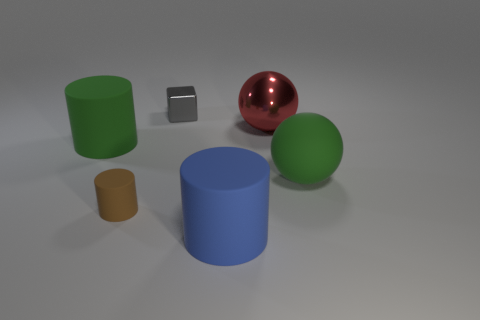How many small objects are either brown cylinders or blocks?
Offer a very short reply. 2. What is the color of the object that is both behind the green rubber cylinder and in front of the small gray block?
Offer a very short reply. Red. Do the brown thing and the green cylinder have the same material?
Ensure brevity in your answer.  Yes. What shape is the brown matte thing?
Ensure brevity in your answer.  Cylinder. There is a small thing in front of the green object that is to the right of the metal cube; what number of big objects are behind it?
Your answer should be compact. 3. There is another object that is the same shape as the red metal object; what color is it?
Make the answer very short. Green. The metallic object behind the sphere that is to the left of the green rubber thing that is on the right side of the large blue object is what shape?
Give a very brief answer. Cube. How big is the matte object that is both left of the metal sphere and behind the small brown thing?
Offer a very short reply. Large. Are there fewer tiny brown matte things than tiny objects?
Keep it short and to the point. Yes. What size is the sphere that is in front of the large green cylinder?
Your response must be concise. Large. 